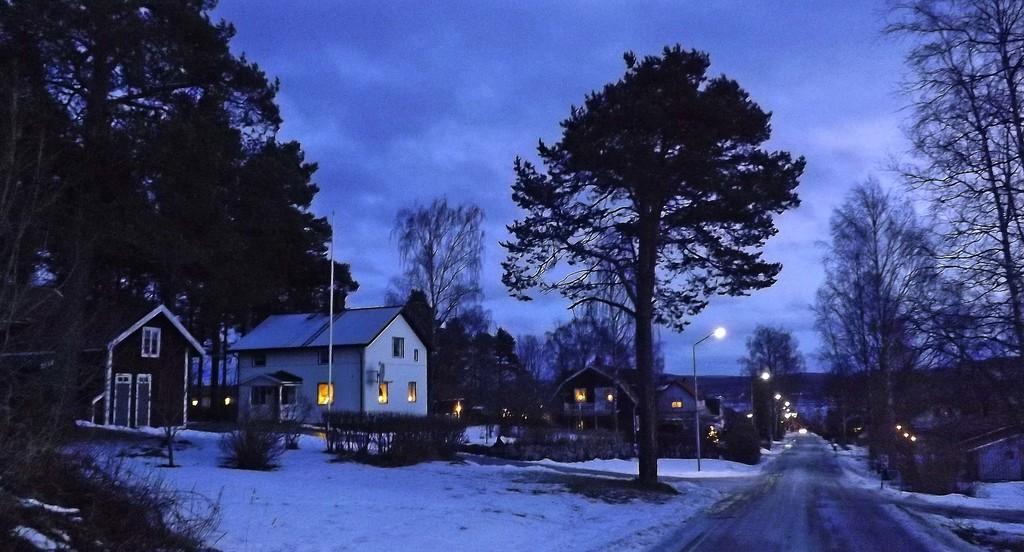How would you summarize this image in a sentence or two? In this picture we can see the beautiful view of the houses and trees. In the front bottom side there is a road in the middle and snow on the ground. On the top there is a sky. 